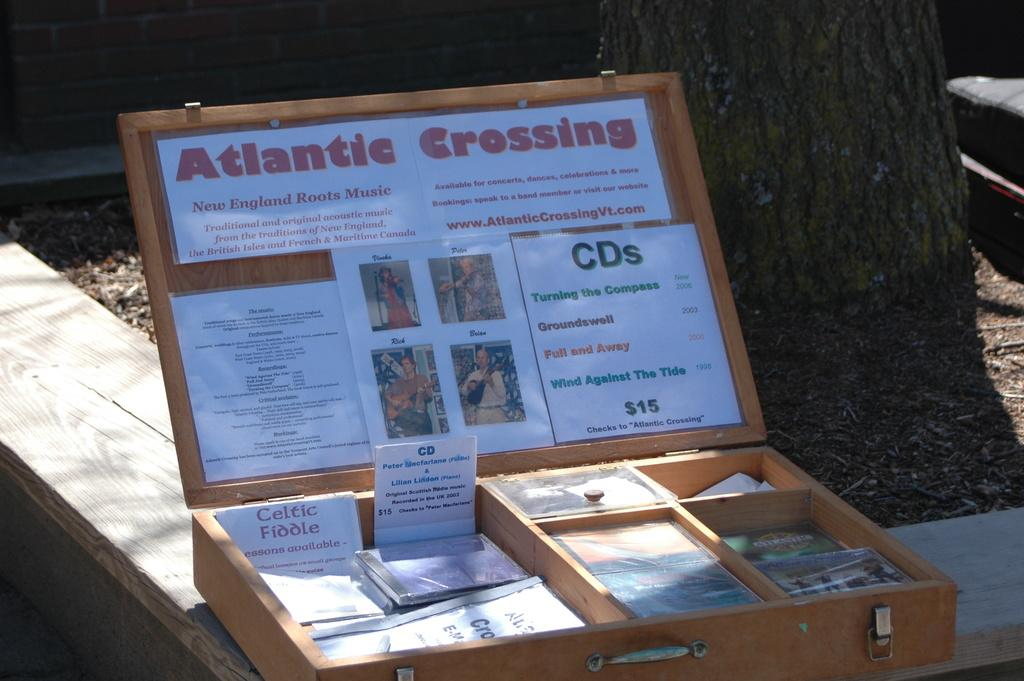<image>
Create a compact narrative representing the image presented. £15 is the cost for a CD of either Turning the compass, Groundswell, Full and away or wind against the tide. 